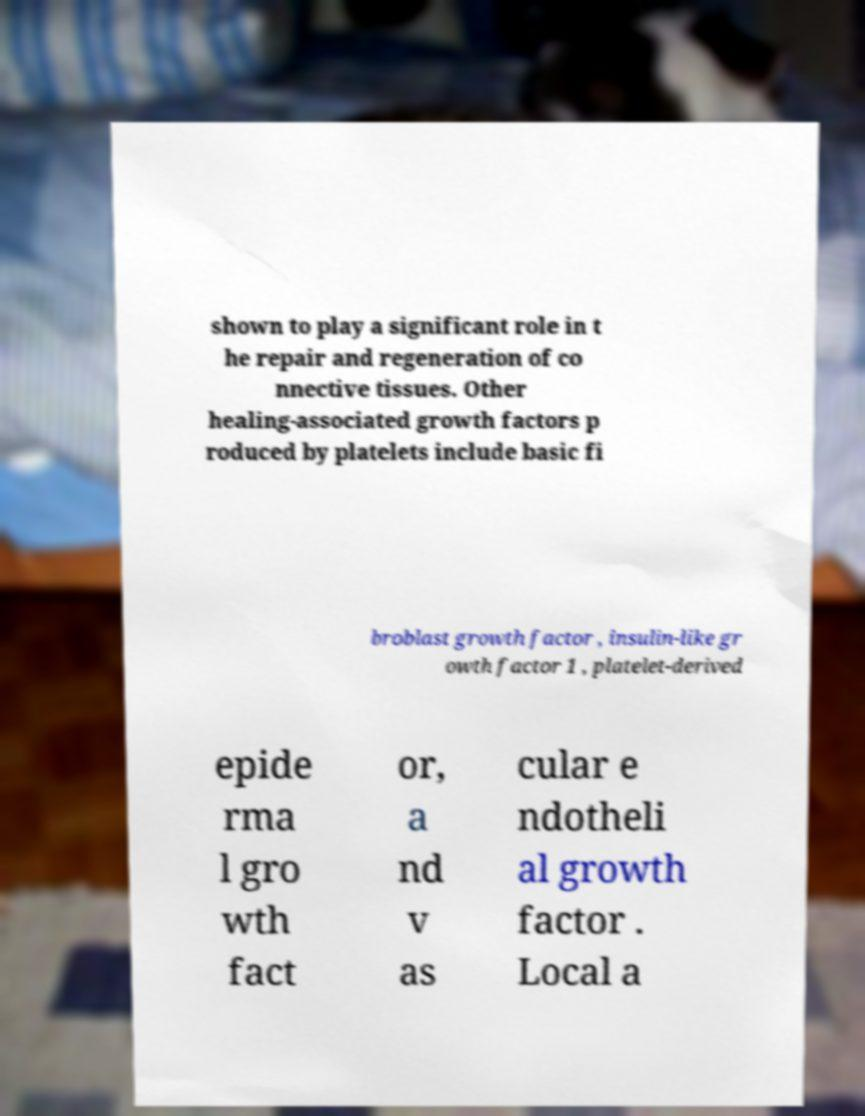Please identify and transcribe the text found in this image. shown to play a significant role in t he repair and regeneration of co nnective tissues. Other healing-associated growth factors p roduced by platelets include basic fi broblast growth factor , insulin-like gr owth factor 1 , platelet-derived epide rma l gro wth fact or, a nd v as cular e ndotheli al growth factor . Local a 